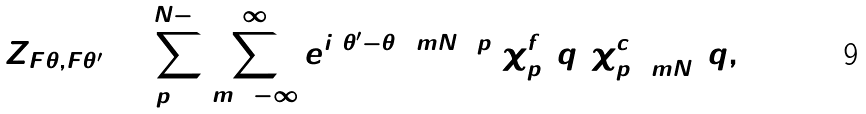Convert formula to latex. <formula><loc_0><loc_0><loc_500><loc_500>Z _ { F \theta , F \theta ^ { \prime } } = \sum _ { p = 0 } ^ { N - 1 } \sum _ { m = - \infty } ^ { \infty } e ^ { i ( \theta ^ { \prime } - \theta ) ( m N + p ) } \chi ^ { f } _ { p } ( \tilde { q } ) \chi ^ { c } _ { p + m N } ( \tilde { q } , 0 )</formula> 